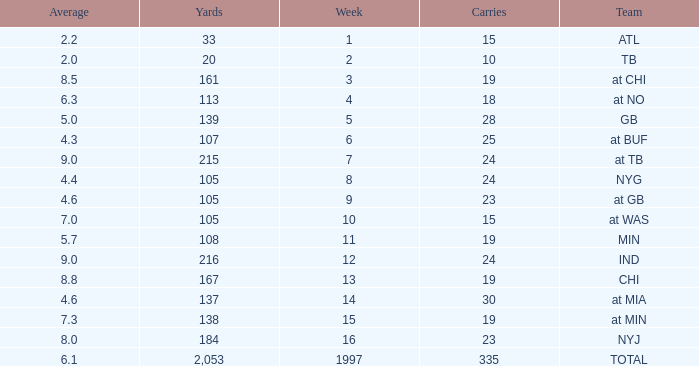Which Team has 19 Carries, and a Week larger than 13? At min. 